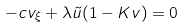<formula> <loc_0><loc_0><loc_500><loc_500>- c v _ { \xi } + \lambda \tilde { u } ( 1 - K v ) = 0</formula> 